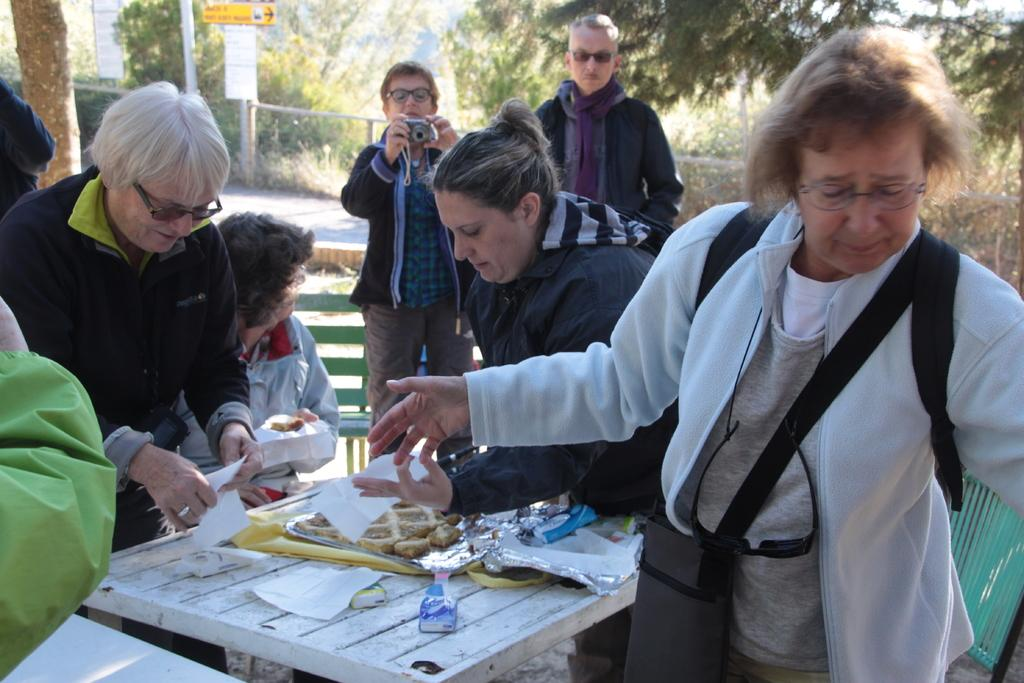Who or what can be seen in the image? There are people in the image. What is on the table in the image? There are objects on a table in the image. What can be seen in the distance in the image? There are trees visible in the background of the image. What color is the dress worn by the person holding the pail in the image? There is no person holding a pail in the image, nor is there a dress present. 